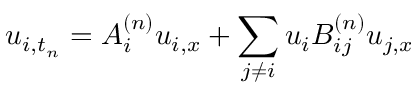Convert formula to latex. <formula><loc_0><loc_0><loc_500><loc_500>u _ { i , t _ { n } } = A _ { i } ^ { ( n ) } u _ { i , x } + \sum _ { j \neq i } u _ { i } B _ { i j } ^ { ( n ) } u _ { j , x }</formula> 